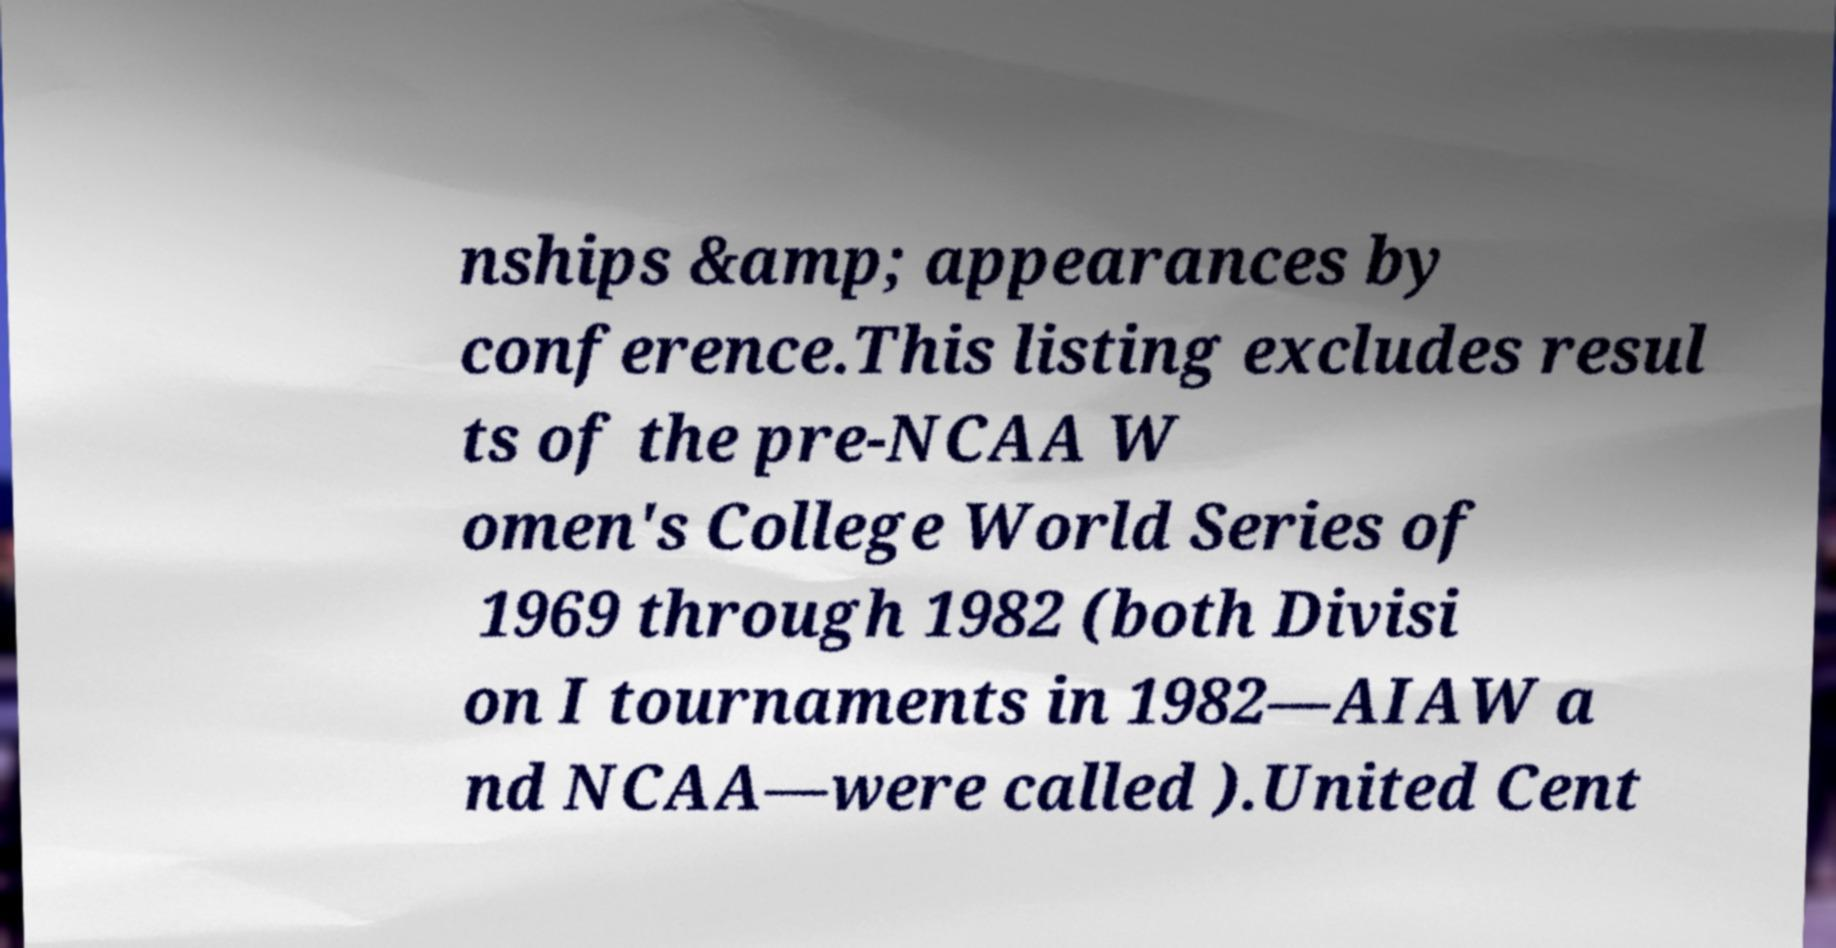For documentation purposes, I need the text within this image transcribed. Could you provide that? nships &amp; appearances by conference.This listing excludes resul ts of the pre-NCAA W omen's College World Series of 1969 through 1982 (both Divisi on I tournaments in 1982—AIAW a nd NCAA—were called ).United Cent 